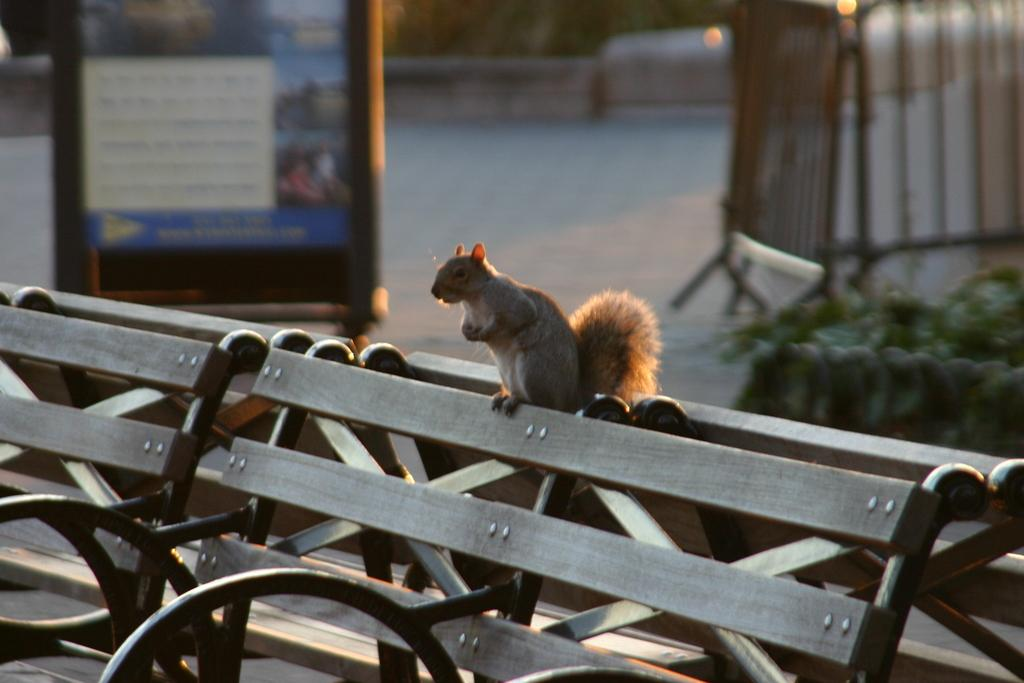What is the main subject in the center of the image? There is a squirrel in the center of the image. Where is the squirrel located? The squirrel is on a bench. What can be seen in the background of the image? There is a banner, metal railing, and a group of plants in the background of the image. What type of zinc is present in the image? There is no zinc present in the image. What town is depicted in the background of the image? The image does not depict a town; it shows a squirrel on a bench with a banner, metal railing, and group of plants in the background. 